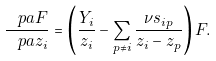Convert formula to latex. <formula><loc_0><loc_0><loc_500><loc_500>\frac { \ p a F } { \ p a z _ { i } } = \left ( \frac { Y _ { i } } { z _ { i } } - \sum _ { p \ne i } \frac { \nu s _ { i p } } { z _ { i } - z _ { p } } \right ) F .</formula> 